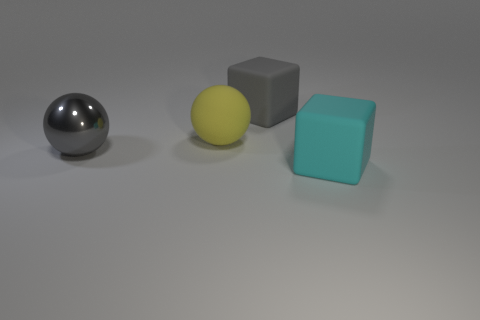What size is the rubber object that is the same color as the large metallic ball?
Provide a succinct answer. Large. How many other things are there of the same color as the metal thing?
Make the answer very short. 1. What material is the gray block?
Offer a terse response. Rubber. There is a thing that is behind the metal sphere and on the right side of the yellow sphere; what is it made of?
Make the answer very short. Rubber. How many things are large rubber things that are on the right side of the matte ball or small cyan blocks?
Ensure brevity in your answer.  2. Does the large rubber ball have the same color as the shiny object?
Provide a short and direct response. No. Are there any metal spheres that have the same size as the gray metal object?
Give a very brief answer. No. How many large gray objects are both left of the big yellow matte sphere and behind the big yellow sphere?
Ensure brevity in your answer.  0. What number of large gray cubes are in front of the big cyan object?
Offer a very short reply. 0. Are there any gray shiny things that have the same shape as the big gray rubber object?
Ensure brevity in your answer.  No. 